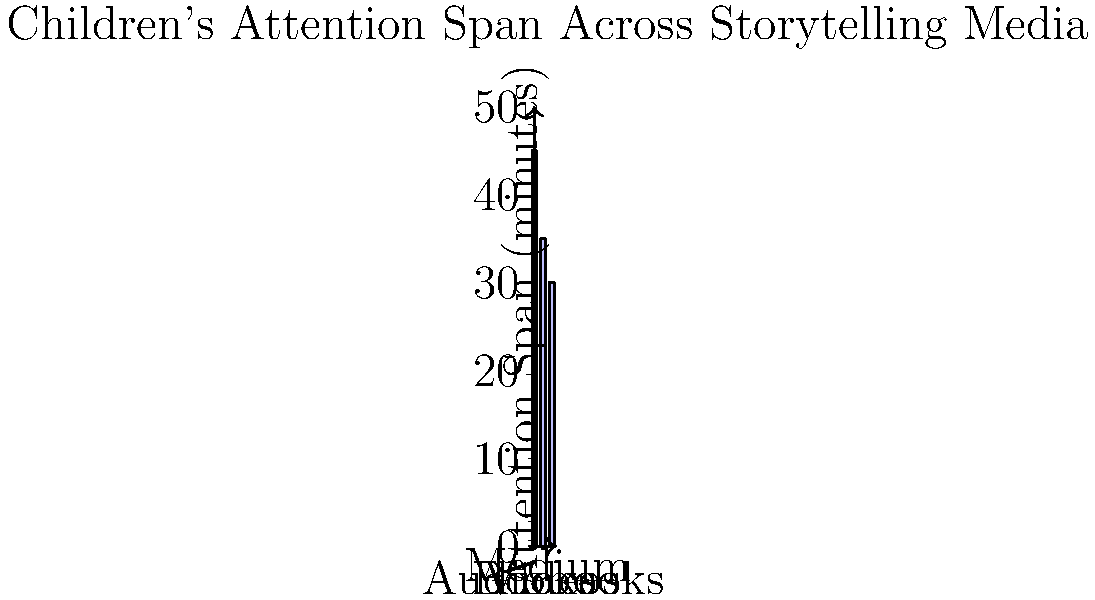Based on the bar graph showing children's attention span across different storytelling media, what is the difference in minutes between the medium with the highest attention span and the medium with the lowest attention span? To find the difference between the highest and lowest attention spans:

1. Identify the highest attention span:
   Books have the highest bar at 45 minutes.

2. Identify the lowest attention span:
   Videos have the lowest bar at 30 minutes.

3. Calculate the difference:
   $45 - 30 = 15$ minutes

Therefore, the difference in attention span between the medium with the highest (books) and lowest (videos) is 15 minutes.
Answer: 15 minutes 